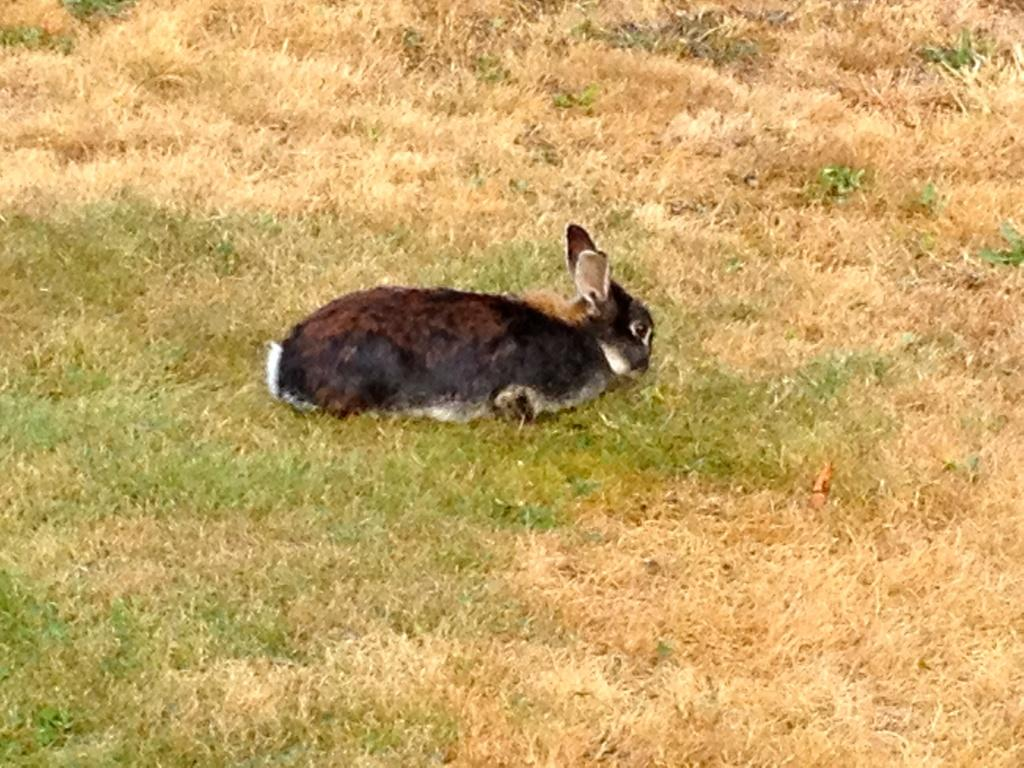What animal is the main subject of the image? There is a rabbit in the image. Where is the rabbit located in the image? The rabbit is in the center of the image. What type of surface is the rabbit on? The rabbit is on the grass. What is the name of the park where the rabbit is crying in the image? There is no park or crying rabbit present in the image; it features a rabbit on the grass. 